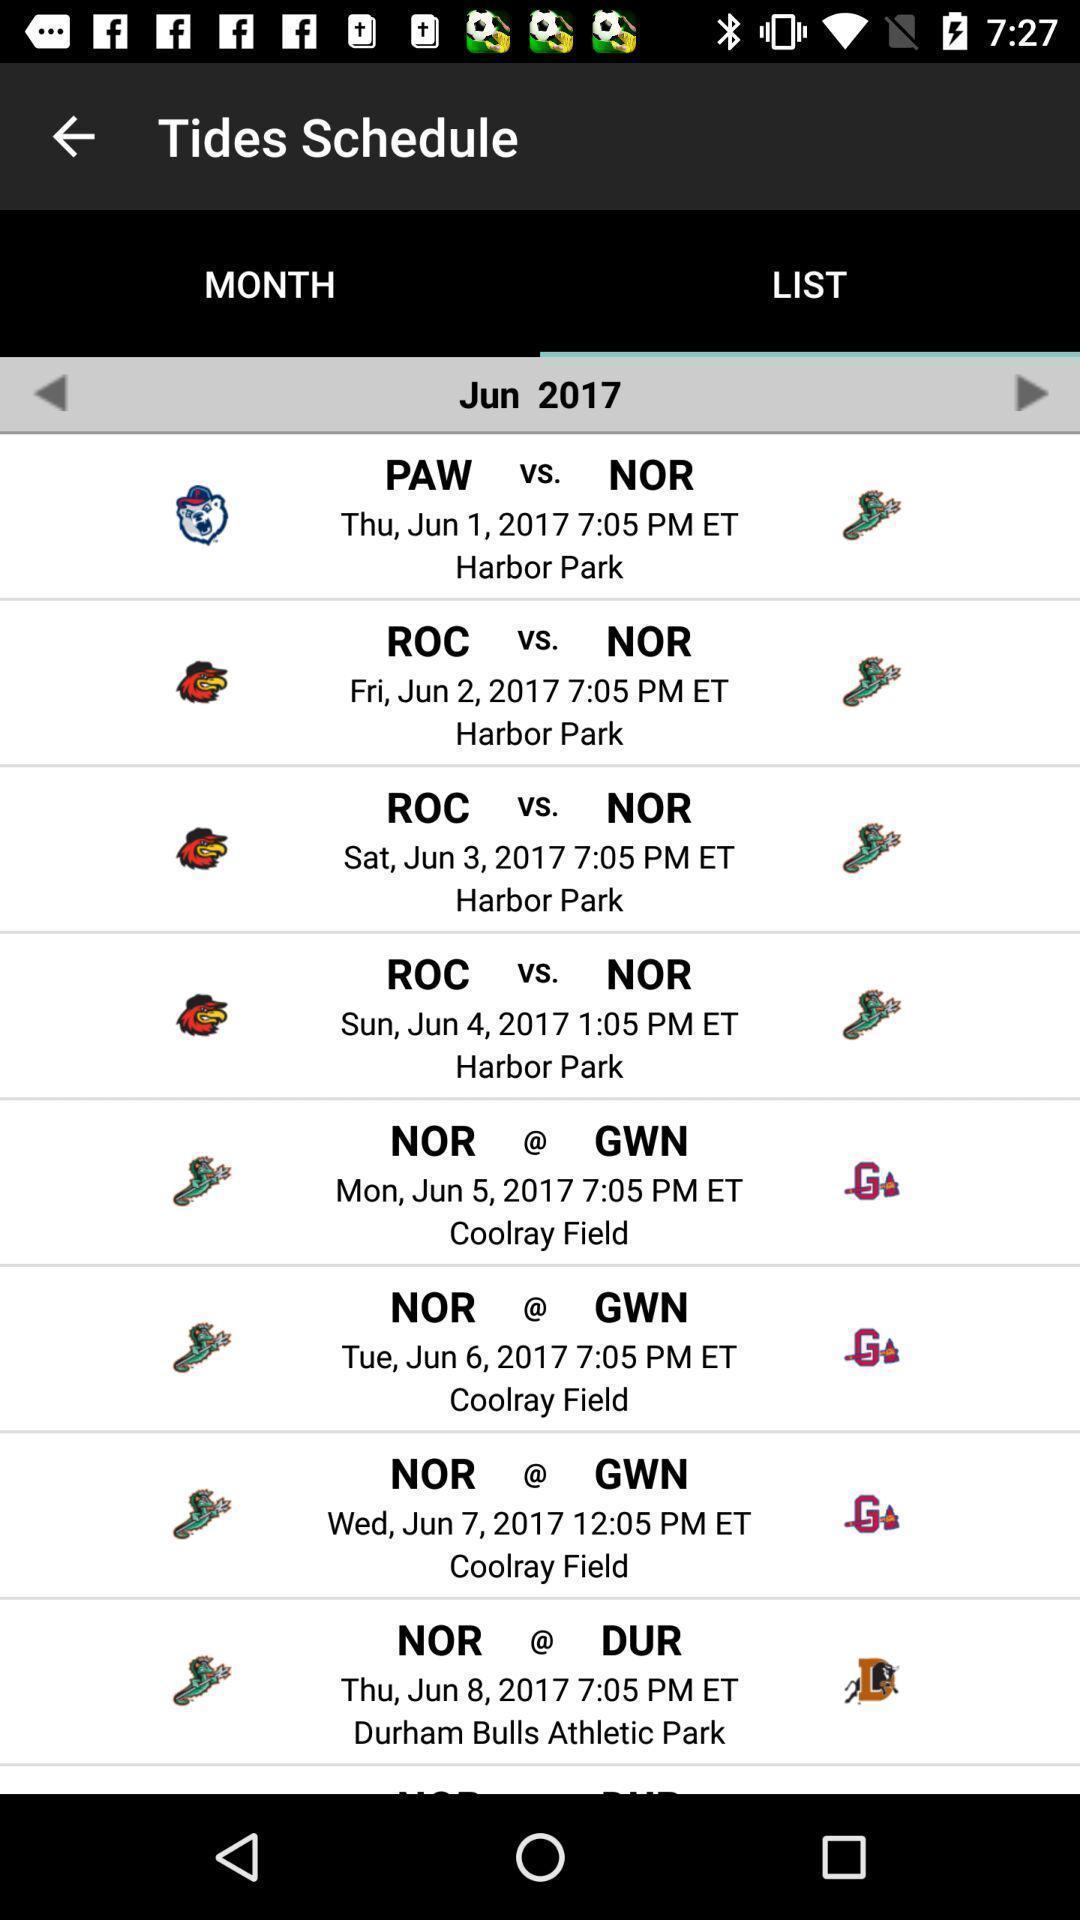Describe this image in words. Page displaying list of teams playing with schedules. 